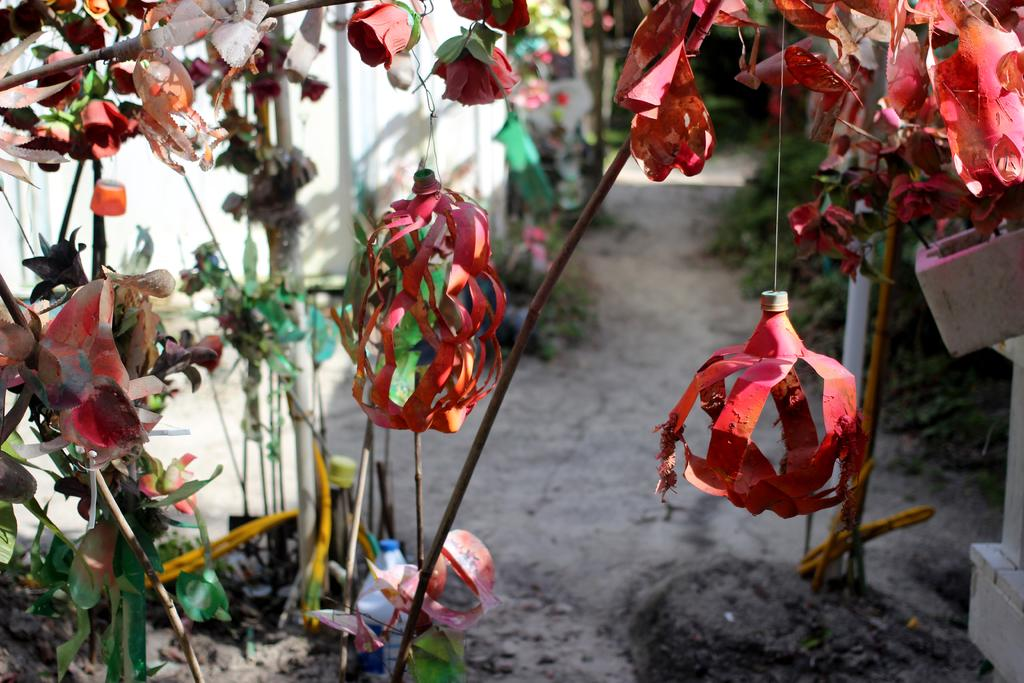What can be seen in the image that adds visual interest? There are decorations in the image. How would you describe the overall appearance of the image? The background of the image is blurred. What type of prose is being read by the manager in the image? There is no manager or prose present in the image. 